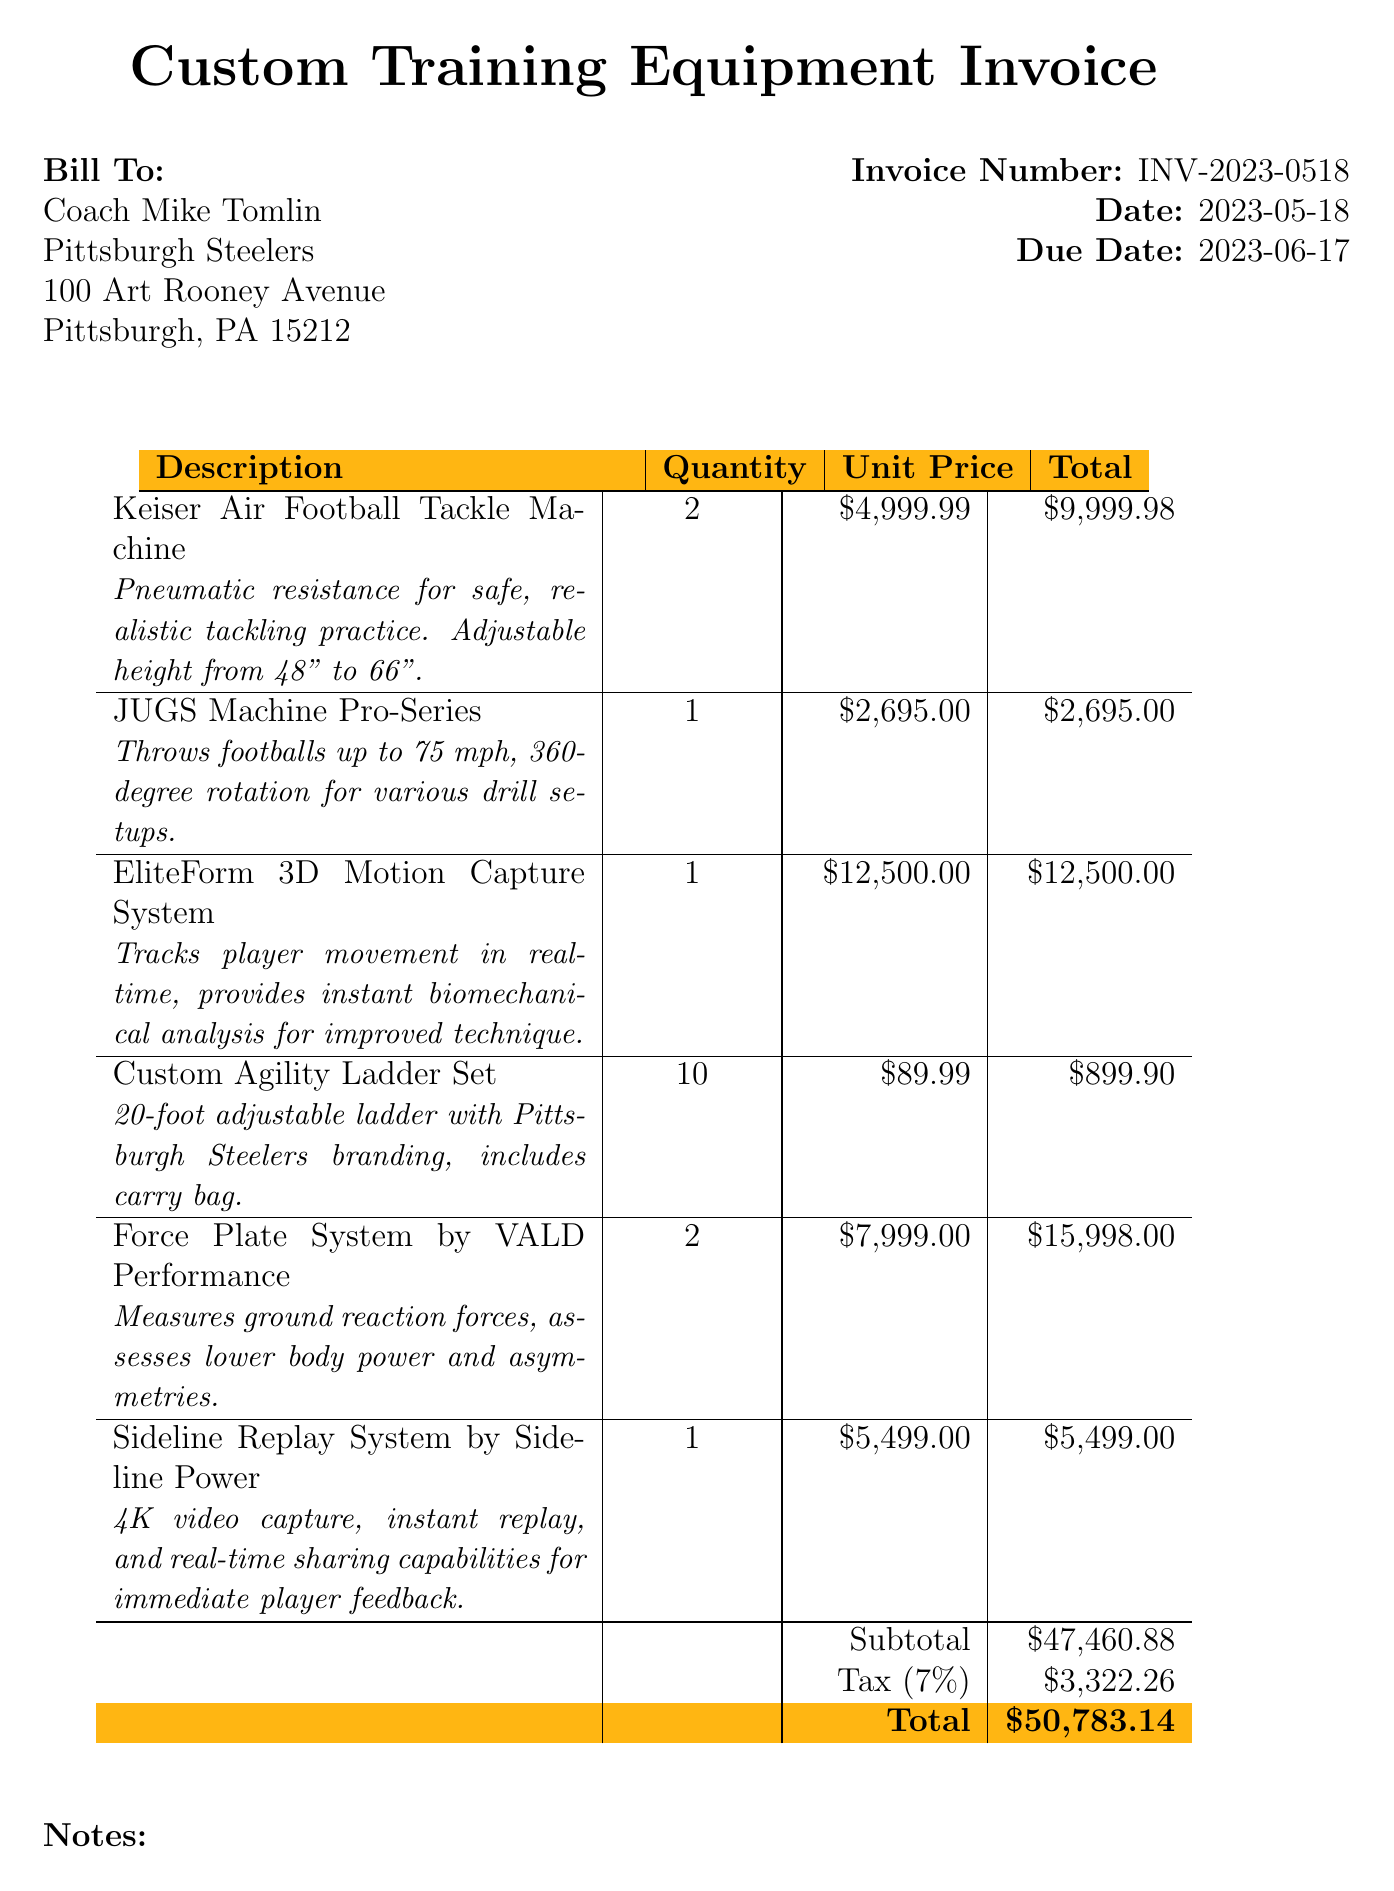What is the invoice number? The invoice number is listed prominently in the document for reference.
Answer: INV-2023-0518 What is the date of the invoice? The date is clearly stated in the document for tracking purposes.
Answer: 2023-05-18 Who is the bill to? The recipient's name and affiliation are specified in the "Bill To" section.
Answer: Coach Mike Tomlin What is the total amount due? The total is calculated at the end of the invoice, summarizing the costs.
Answer: $50,783.14 How many Keiser Air Football Tackle Machines are ordered? The quantity is specified next to the item description in the list.
Answer: 2 What is the tax rate applied? The document provides this information explicitly after the subtotal.
Answer: 7% What type of system is the EliteForm 3D Motion Capture System? The specifications state its purpose and technology clearly.
Answer: Biomechanical analysis What does the Sideline Replay System do? The specifications outline its main functions regarding video capabilities.
Answer: Instant replay How many Custom Agility Ladder Sets are included? The quantity for this item is mentioned explicitly in the invoice.
Answer: 10 What is included with the purchase according to the notes? The notes at the bottom provide details on additional services offered.
Answer: Installation and initial staff training 